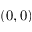<formula> <loc_0><loc_0><loc_500><loc_500>( 0 , 0 )</formula> 